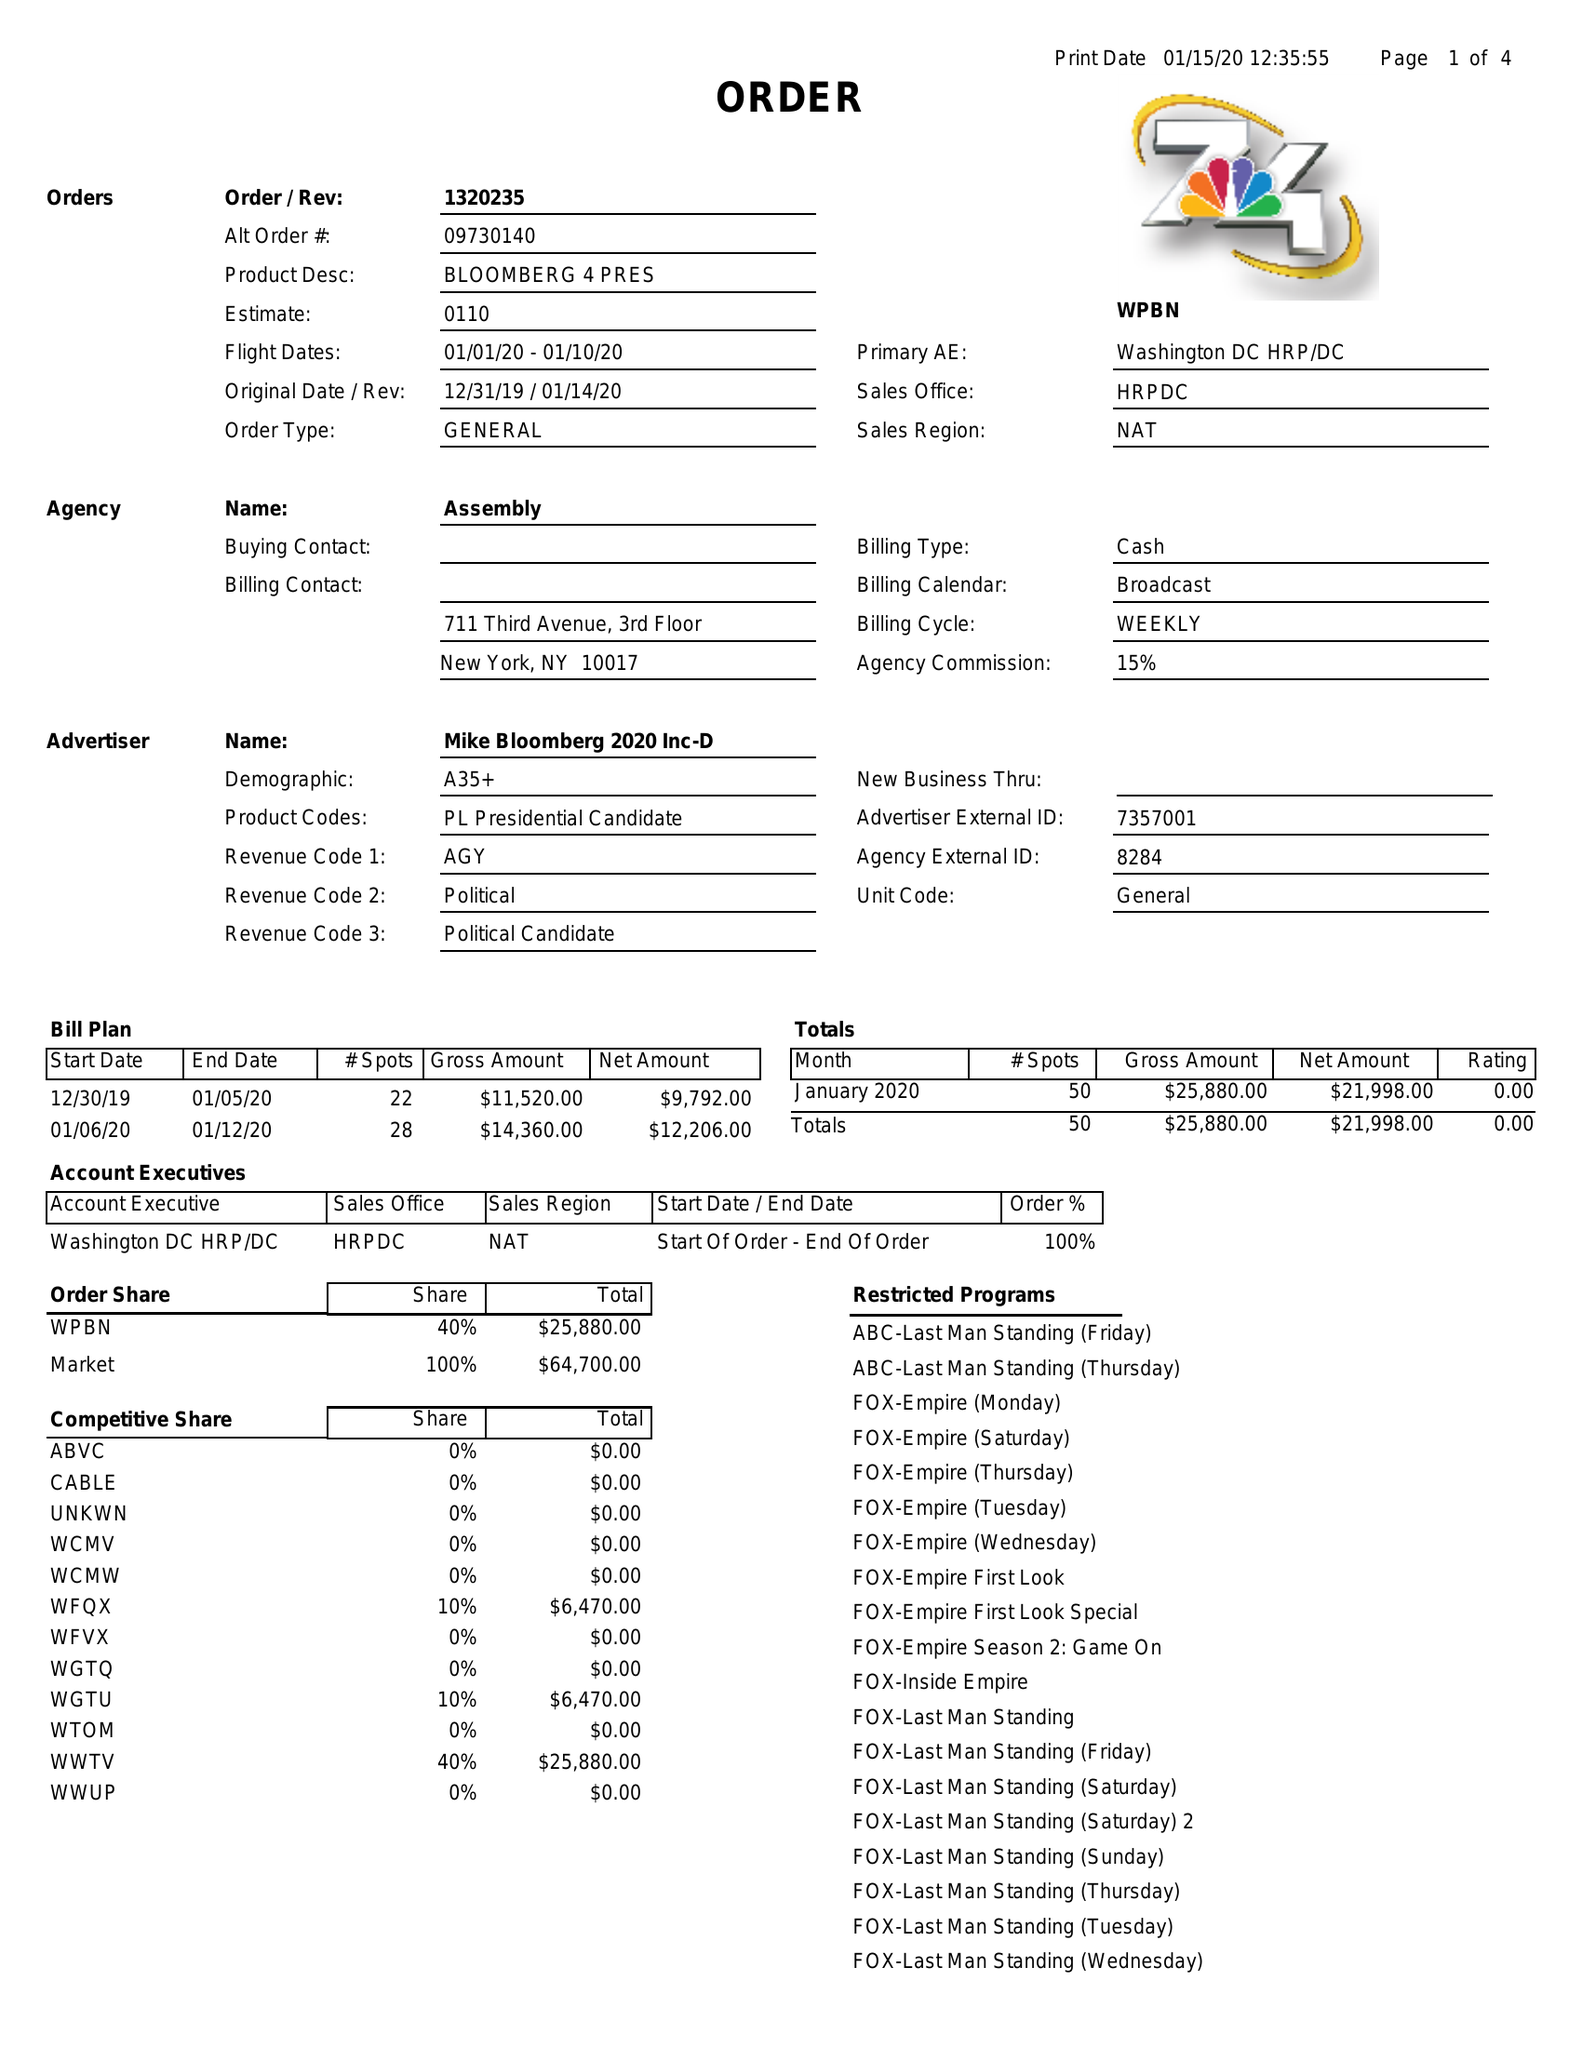What is the value for the flight_from?
Answer the question using a single word or phrase. 01/01/20 